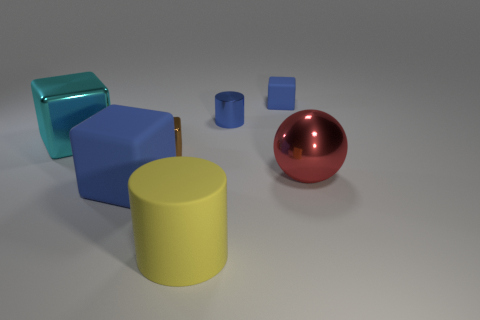There is a small block in front of the tiny blue metallic cylinder; what color is it?
Make the answer very short. Brown. What is the material of the big thing that is the same color as the metallic cylinder?
Give a very brief answer. Rubber. Is there a tiny brown shiny thing that has the same shape as the big cyan thing?
Your answer should be compact. Yes. What number of brown things have the same shape as the small blue metallic thing?
Offer a terse response. 0. Is the small cylinder the same color as the big metal sphere?
Provide a succinct answer. No. Is the number of large cyan cylinders less than the number of tiny blue cylinders?
Your answer should be compact. Yes. What is the big red sphere in front of the big cyan shiny thing made of?
Give a very brief answer. Metal. What material is the cyan block that is the same size as the yellow rubber thing?
Your answer should be compact. Metal. What is the material of the large cylinder on the left side of the large metallic thing in front of the large cyan metal object that is to the left of the tiny brown block?
Keep it short and to the point. Rubber. There is a cylinder that is in front of the sphere; does it have the same size as the tiny rubber thing?
Offer a terse response. No. 